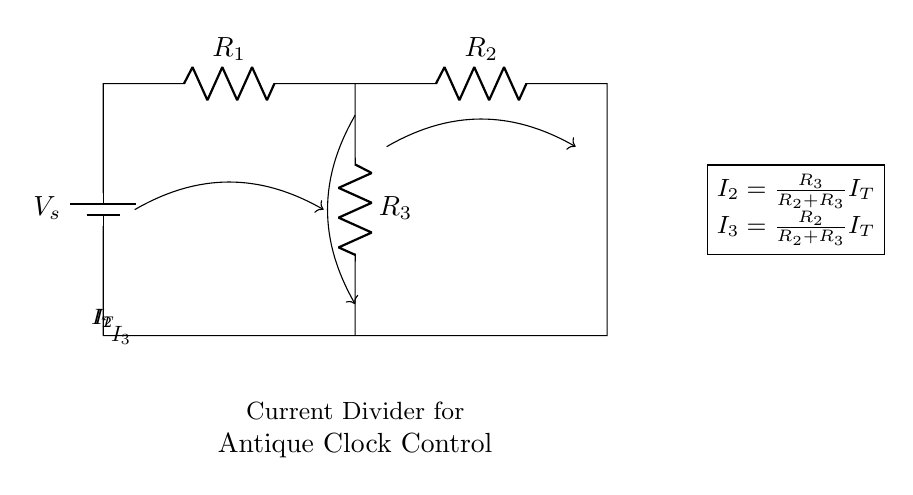What is the voltage source label in the circuit? The voltage source in the circuit is labeled as V_s, indicating the supply voltage for the circuit components.
Answer: V_s What are the resistor labels in the diagram? The resistors in the diagram are labeled as R_1, R_2, and R_3, each denoting different resistance values in the current divider network.
Answer: R_1, R_2, R_3 What is the total current entering the circuit labeled as? The total current entering the circuit is labeled as I_T, representing the input current flowing into the current divider circuit.
Answer: I_T Which resistor carries the current I_3? The current I_3 flows through the resistor R_3, as indicated by the connection and the label in the circuit diagram.
Answer: R_3 How is the current I_2 calculated? The current I_2 is calculated using the formula I_2 = (R_3 / (R_2 + R_3)) * I_T, which shows how the total current is split based on the resistance values.
Answer: R_3 / (R_2 + R_3) I_T Which type of circuit is depicted in this diagram? The diagram represents a current divider circuit, a configuration that splits the current into multiple branches based on the resistor values.
Answer: Current Divider 